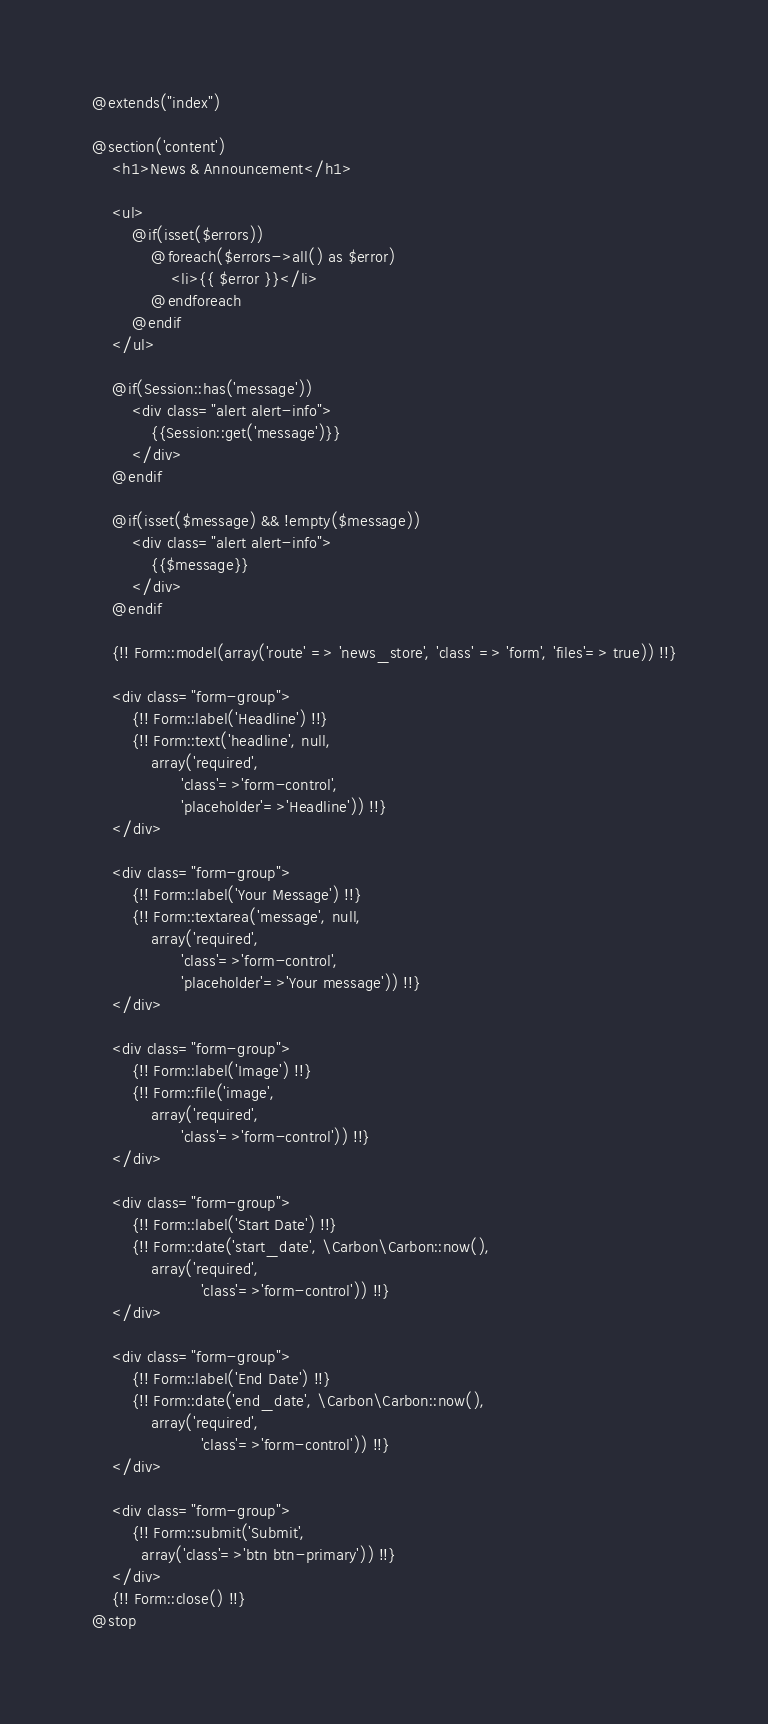Convert code to text. <code><loc_0><loc_0><loc_500><loc_500><_PHP_>@extends("index")

@section('content')
    <h1>News & Announcement</h1>

    <ul>
        @if(isset($errors))
            @foreach($errors->all() as $error)
                <li>{{ $error }}</li>
            @endforeach
        @endif
    </ul>

    @if(Session::has('message'))
        <div class="alert alert-info">
            {{Session::get('message')}}
        </div>
    @endif

    @if(isset($message) && !empty($message))
        <div class="alert alert-info">
            {{$message}}
        </div>
    @endif

    {!! Form::model(array('route' => 'news_store', 'class' => 'form', 'files'=> true)) !!}

    <div class="form-group">
        {!! Form::label('Headline') !!}
        {!! Form::text('headline', null,
            array('required',
                  'class'=>'form-control',
                  'placeholder'=>'Headline')) !!}
    </div>

    <div class="form-group">
        {!! Form::label('Your Message') !!}
        {!! Form::textarea('message', null,
            array('required',
                  'class'=>'form-control',
                  'placeholder'=>'Your message')) !!}
    </div>

    <div class="form-group">
        {!! Form::label('Image') !!}
        {!! Form::file('image',
            array('required',
                  'class'=>'form-control')) !!}
    </div>

    <div class="form-group">
        {!! Form::label('Start Date') !!}
        {!! Form::date('start_date', \Carbon\Carbon::now(),
            array('required',
                      'class'=>'form-control')) !!}
    </div>

    <div class="form-group">
        {!! Form::label('End Date') !!}
        {!! Form::date('end_date', \Carbon\Carbon::now(),
            array('required',
                      'class'=>'form-control')) !!}
    </div>

    <div class="form-group">
        {!! Form::submit('Submit',
          array('class'=>'btn btn-primary')) !!}
    </div>
    {!! Form::close() !!}
@stop</code> 